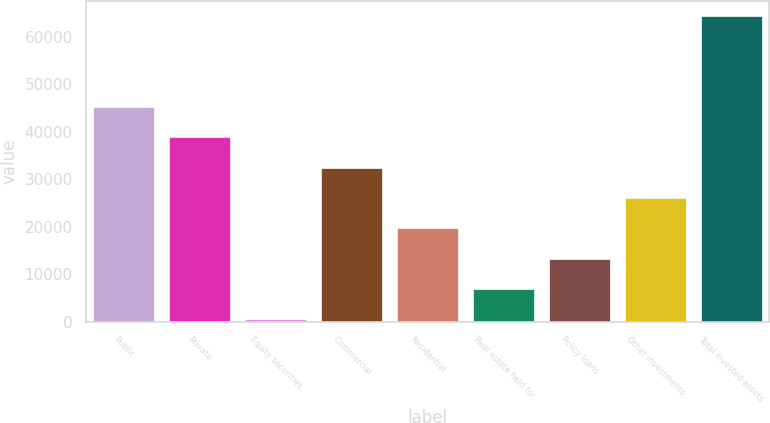<chart> <loc_0><loc_0><loc_500><loc_500><bar_chart><fcel>Public<fcel>Private<fcel>Equity securities<fcel>Commercial<fcel>Residential<fcel>Real estate held for<fcel>Policy loans<fcel>Other investments<fcel>Total invested assets<nl><fcel>45231.4<fcel>38853.5<fcel>586.2<fcel>32475.6<fcel>19719.8<fcel>6964.08<fcel>13342<fcel>26097.7<fcel>64365<nl></chart> 